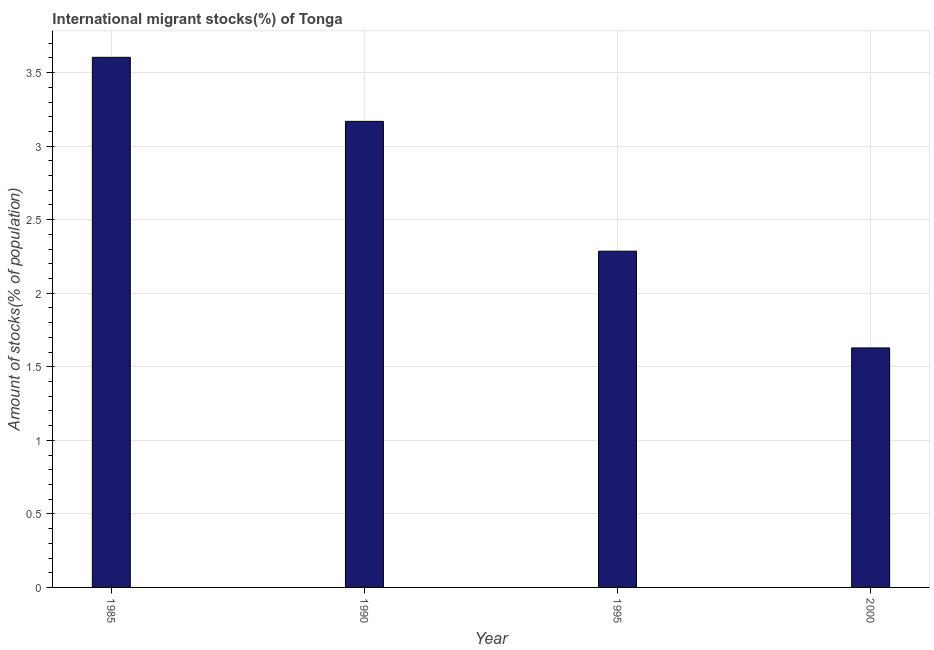Does the graph contain any zero values?
Your response must be concise. No. Does the graph contain grids?
Your answer should be very brief. Yes. What is the title of the graph?
Keep it short and to the point. International migrant stocks(%) of Tonga. What is the label or title of the Y-axis?
Provide a succinct answer. Amount of stocks(% of population). What is the number of international migrant stocks in 1995?
Your answer should be very brief. 2.29. Across all years, what is the maximum number of international migrant stocks?
Your response must be concise. 3.6. Across all years, what is the minimum number of international migrant stocks?
Provide a short and direct response. 1.63. In which year was the number of international migrant stocks minimum?
Your response must be concise. 2000. What is the sum of the number of international migrant stocks?
Ensure brevity in your answer.  10.69. What is the difference between the number of international migrant stocks in 1985 and 1995?
Provide a succinct answer. 1.32. What is the average number of international migrant stocks per year?
Ensure brevity in your answer.  2.67. What is the median number of international migrant stocks?
Keep it short and to the point. 2.73. What is the ratio of the number of international migrant stocks in 1985 to that in 1990?
Ensure brevity in your answer.  1.14. Is the number of international migrant stocks in 1990 less than that in 1995?
Offer a terse response. No. Is the difference between the number of international migrant stocks in 1990 and 1995 greater than the difference between any two years?
Provide a succinct answer. No. What is the difference between the highest and the second highest number of international migrant stocks?
Your answer should be compact. 0.43. What is the difference between the highest and the lowest number of international migrant stocks?
Make the answer very short. 1.98. In how many years, is the number of international migrant stocks greater than the average number of international migrant stocks taken over all years?
Keep it short and to the point. 2. How many bars are there?
Your answer should be compact. 4. Are all the bars in the graph horizontal?
Your response must be concise. No. What is the Amount of stocks(% of population) in 1985?
Give a very brief answer. 3.6. What is the Amount of stocks(% of population) in 1990?
Provide a succinct answer. 3.17. What is the Amount of stocks(% of population) in 1995?
Provide a succinct answer. 2.29. What is the Amount of stocks(% of population) in 2000?
Give a very brief answer. 1.63. What is the difference between the Amount of stocks(% of population) in 1985 and 1990?
Make the answer very short. 0.44. What is the difference between the Amount of stocks(% of population) in 1985 and 1995?
Keep it short and to the point. 1.32. What is the difference between the Amount of stocks(% of population) in 1985 and 2000?
Offer a terse response. 1.98. What is the difference between the Amount of stocks(% of population) in 1990 and 1995?
Provide a short and direct response. 0.88. What is the difference between the Amount of stocks(% of population) in 1990 and 2000?
Provide a short and direct response. 1.54. What is the difference between the Amount of stocks(% of population) in 1995 and 2000?
Your response must be concise. 0.66. What is the ratio of the Amount of stocks(% of population) in 1985 to that in 1990?
Give a very brief answer. 1.14. What is the ratio of the Amount of stocks(% of population) in 1985 to that in 1995?
Give a very brief answer. 1.58. What is the ratio of the Amount of stocks(% of population) in 1985 to that in 2000?
Keep it short and to the point. 2.21. What is the ratio of the Amount of stocks(% of population) in 1990 to that in 1995?
Provide a short and direct response. 1.39. What is the ratio of the Amount of stocks(% of population) in 1990 to that in 2000?
Offer a very short reply. 1.95. What is the ratio of the Amount of stocks(% of population) in 1995 to that in 2000?
Your answer should be very brief. 1.4. 